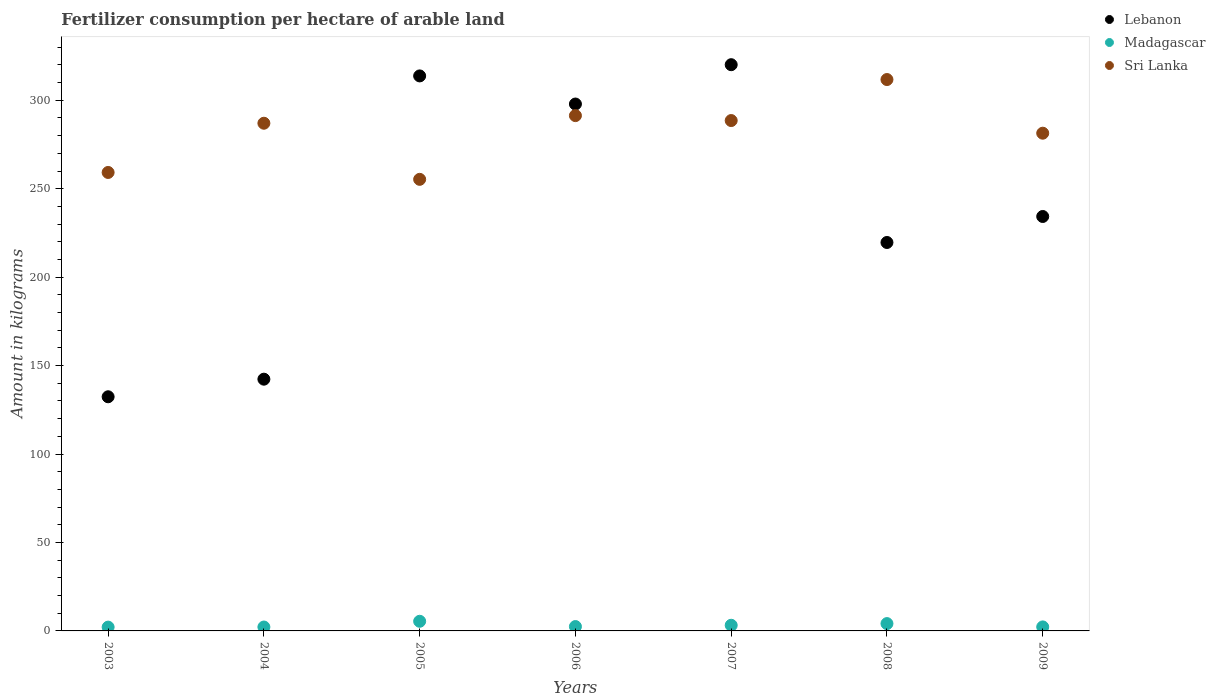Is the number of dotlines equal to the number of legend labels?
Your response must be concise. Yes. What is the amount of fertilizer consumption in Lebanon in 2007?
Make the answer very short. 320.1. Across all years, what is the maximum amount of fertilizer consumption in Lebanon?
Keep it short and to the point. 320.1. Across all years, what is the minimum amount of fertilizer consumption in Sri Lanka?
Ensure brevity in your answer.  255.29. In which year was the amount of fertilizer consumption in Madagascar maximum?
Your answer should be very brief. 2005. In which year was the amount of fertilizer consumption in Lebanon minimum?
Provide a succinct answer. 2003. What is the total amount of fertilizer consumption in Madagascar in the graph?
Provide a succinct answer. 21.87. What is the difference between the amount of fertilizer consumption in Sri Lanka in 2005 and that in 2006?
Provide a succinct answer. -36.02. What is the difference between the amount of fertilizer consumption in Lebanon in 2006 and the amount of fertilizer consumption in Madagascar in 2004?
Your response must be concise. 295.66. What is the average amount of fertilizer consumption in Madagascar per year?
Provide a succinct answer. 3.12. In the year 2008, what is the difference between the amount of fertilizer consumption in Sri Lanka and amount of fertilizer consumption in Madagascar?
Offer a very short reply. 307.57. What is the ratio of the amount of fertilizer consumption in Madagascar in 2006 to that in 2007?
Keep it short and to the point. 0.77. Is the difference between the amount of fertilizer consumption in Sri Lanka in 2004 and 2005 greater than the difference between the amount of fertilizer consumption in Madagascar in 2004 and 2005?
Provide a succinct answer. Yes. What is the difference between the highest and the second highest amount of fertilizer consumption in Sri Lanka?
Offer a terse response. 20.4. What is the difference between the highest and the lowest amount of fertilizer consumption in Madagascar?
Make the answer very short. 3.3. Is the sum of the amount of fertilizer consumption in Madagascar in 2003 and 2005 greater than the maximum amount of fertilizer consumption in Sri Lanka across all years?
Keep it short and to the point. No. Is it the case that in every year, the sum of the amount of fertilizer consumption in Sri Lanka and amount of fertilizer consumption in Madagascar  is greater than the amount of fertilizer consumption in Lebanon?
Offer a very short reply. No. Is the amount of fertilizer consumption in Madagascar strictly greater than the amount of fertilizer consumption in Lebanon over the years?
Give a very brief answer. No. Are the values on the major ticks of Y-axis written in scientific E-notation?
Provide a succinct answer. No. Does the graph contain any zero values?
Offer a terse response. No. Does the graph contain grids?
Your answer should be compact. No. How many legend labels are there?
Ensure brevity in your answer.  3. How are the legend labels stacked?
Your response must be concise. Vertical. What is the title of the graph?
Your answer should be compact. Fertilizer consumption per hectare of arable land. What is the label or title of the X-axis?
Give a very brief answer. Years. What is the label or title of the Y-axis?
Keep it short and to the point. Amount in kilograms. What is the Amount in kilograms of Lebanon in 2003?
Offer a terse response. 132.38. What is the Amount in kilograms in Madagascar in 2003?
Offer a terse response. 2.15. What is the Amount in kilograms in Sri Lanka in 2003?
Your answer should be very brief. 259.18. What is the Amount in kilograms of Lebanon in 2004?
Your answer should be very brief. 142.32. What is the Amount in kilograms in Madagascar in 2004?
Provide a short and direct response. 2.2. What is the Amount in kilograms in Sri Lanka in 2004?
Offer a very short reply. 287.01. What is the Amount in kilograms in Lebanon in 2005?
Provide a succinct answer. 313.76. What is the Amount in kilograms in Madagascar in 2005?
Offer a very short reply. 5.45. What is the Amount in kilograms in Sri Lanka in 2005?
Give a very brief answer. 255.29. What is the Amount in kilograms in Lebanon in 2006?
Ensure brevity in your answer.  297.87. What is the Amount in kilograms in Madagascar in 2006?
Your answer should be very brief. 2.47. What is the Amount in kilograms in Sri Lanka in 2006?
Provide a succinct answer. 291.32. What is the Amount in kilograms in Lebanon in 2007?
Your response must be concise. 320.1. What is the Amount in kilograms of Madagascar in 2007?
Ensure brevity in your answer.  3.19. What is the Amount in kilograms in Sri Lanka in 2007?
Give a very brief answer. 288.52. What is the Amount in kilograms of Lebanon in 2008?
Make the answer very short. 219.59. What is the Amount in kilograms in Madagascar in 2008?
Give a very brief answer. 4.14. What is the Amount in kilograms in Sri Lanka in 2008?
Your answer should be compact. 311.71. What is the Amount in kilograms in Lebanon in 2009?
Offer a very short reply. 234.29. What is the Amount in kilograms in Madagascar in 2009?
Your response must be concise. 2.27. What is the Amount in kilograms in Sri Lanka in 2009?
Ensure brevity in your answer.  281.38. Across all years, what is the maximum Amount in kilograms of Lebanon?
Your response must be concise. 320.1. Across all years, what is the maximum Amount in kilograms of Madagascar?
Ensure brevity in your answer.  5.45. Across all years, what is the maximum Amount in kilograms of Sri Lanka?
Give a very brief answer. 311.71. Across all years, what is the minimum Amount in kilograms of Lebanon?
Offer a terse response. 132.38. Across all years, what is the minimum Amount in kilograms of Madagascar?
Your answer should be very brief. 2.15. Across all years, what is the minimum Amount in kilograms of Sri Lanka?
Ensure brevity in your answer.  255.29. What is the total Amount in kilograms of Lebanon in the graph?
Keep it short and to the point. 1660.31. What is the total Amount in kilograms of Madagascar in the graph?
Offer a terse response. 21.87. What is the total Amount in kilograms of Sri Lanka in the graph?
Provide a succinct answer. 1974.41. What is the difference between the Amount in kilograms of Lebanon in 2003 and that in 2004?
Keep it short and to the point. -9.94. What is the difference between the Amount in kilograms in Madagascar in 2003 and that in 2004?
Your answer should be very brief. -0.05. What is the difference between the Amount in kilograms in Sri Lanka in 2003 and that in 2004?
Make the answer very short. -27.83. What is the difference between the Amount in kilograms in Lebanon in 2003 and that in 2005?
Your response must be concise. -181.39. What is the difference between the Amount in kilograms in Madagascar in 2003 and that in 2005?
Your answer should be very brief. -3.3. What is the difference between the Amount in kilograms of Sri Lanka in 2003 and that in 2005?
Your answer should be very brief. 3.89. What is the difference between the Amount in kilograms in Lebanon in 2003 and that in 2006?
Make the answer very short. -165.49. What is the difference between the Amount in kilograms of Madagascar in 2003 and that in 2006?
Make the answer very short. -0.32. What is the difference between the Amount in kilograms in Sri Lanka in 2003 and that in 2006?
Ensure brevity in your answer.  -32.13. What is the difference between the Amount in kilograms of Lebanon in 2003 and that in 2007?
Keep it short and to the point. -187.73. What is the difference between the Amount in kilograms of Madagascar in 2003 and that in 2007?
Provide a succinct answer. -1.04. What is the difference between the Amount in kilograms of Sri Lanka in 2003 and that in 2007?
Offer a very short reply. -29.34. What is the difference between the Amount in kilograms of Lebanon in 2003 and that in 2008?
Your answer should be compact. -87.22. What is the difference between the Amount in kilograms of Madagascar in 2003 and that in 2008?
Give a very brief answer. -1.99. What is the difference between the Amount in kilograms of Sri Lanka in 2003 and that in 2008?
Keep it short and to the point. -52.53. What is the difference between the Amount in kilograms in Lebanon in 2003 and that in 2009?
Offer a very short reply. -101.92. What is the difference between the Amount in kilograms in Madagascar in 2003 and that in 2009?
Offer a very short reply. -0.12. What is the difference between the Amount in kilograms of Sri Lanka in 2003 and that in 2009?
Provide a short and direct response. -22.19. What is the difference between the Amount in kilograms of Lebanon in 2004 and that in 2005?
Your answer should be compact. -171.44. What is the difference between the Amount in kilograms in Madagascar in 2004 and that in 2005?
Ensure brevity in your answer.  -3.25. What is the difference between the Amount in kilograms in Sri Lanka in 2004 and that in 2005?
Your answer should be compact. 31.72. What is the difference between the Amount in kilograms in Lebanon in 2004 and that in 2006?
Your answer should be compact. -155.55. What is the difference between the Amount in kilograms of Madagascar in 2004 and that in 2006?
Provide a short and direct response. -0.26. What is the difference between the Amount in kilograms in Sri Lanka in 2004 and that in 2006?
Provide a short and direct response. -4.31. What is the difference between the Amount in kilograms in Lebanon in 2004 and that in 2007?
Keep it short and to the point. -177.79. What is the difference between the Amount in kilograms in Madagascar in 2004 and that in 2007?
Offer a terse response. -0.99. What is the difference between the Amount in kilograms of Sri Lanka in 2004 and that in 2007?
Your response must be concise. -1.51. What is the difference between the Amount in kilograms of Lebanon in 2004 and that in 2008?
Provide a short and direct response. -77.28. What is the difference between the Amount in kilograms of Madagascar in 2004 and that in 2008?
Your response must be concise. -1.94. What is the difference between the Amount in kilograms of Sri Lanka in 2004 and that in 2008?
Make the answer very short. -24.7. What is the difference between the Amount in kilograms in Lebanon in 2004 and that in 2009?
Provide a short and direct response. -91.97. What is the difference between the Amount in kilograms of Madagascar in 2004 and that in 2009?
Your response must be concise. -0.06. What is the difference between the Amount in kilograms in Sri Lanka in 2004 and that in 2009?
Give a very brief answer. 5.63. What is the difference between the Amount in kilograms in Lebanon in 2005 and that in 2006?
Your response must be concise. 15.89. What is the difference between the Amount in kilograms in Madagascar in 2005 and that in 2006?
Your answer should be very brief. 2.98. What is the difference between the Amount in kilograms in Sri Lanka in 2005 and that in 2006?
Ensure brevity in your answer.  -36.02. What is the difference between the Amount in kilograms in Lebanon in 2005 and that in 2007?
Provide a succinct answer. -6.34. What is the difference between the Amount in kilograms in Madagascar in 2005 and that in 2007?
Keep it short and to the point. 2.26. What is the difference between the Amount in kilograms in Sri Lanka in 2005 and that in 2007?
Offer a very short reply. -33.23. What is the difference between the Amount in kilograms of Lebanon in 2005 and that in 2008?
Provide a succinct answer. 94.17. What is the difference between the Amount in kilograms in Madagascar in 2005 and that in 2008?
Make the answer very short. 1.31. What is the difference between the Amount in kilograms in Sri Lanka in 2005 and that in 2008?
Your answer should be compact. -56.42. What is the difference between the Amount in kilograms of Lebanon in 2005 and that in 2009?
Offer a terse response. 79.47. What is the difference between the Amount in kilograms of Madagascar in 2005 and that in 2009?
Give a very brief answer. 3.18. What is the difference between the Amount in kilograms of Sri Lanka in 2005 and that in 2009?
Your answer should be very brief. -26.08. What is the difference between the Amount in kilograms in Lebanon in 2006 and that in 2007?
Your response must be concise. -22.24. What is the difference between the Amount in kilograms in Madagascar in 2006 and that in 2007?
Give a very brief answer. -0.73. What is the difference between the Amount in kilograms in Sri Lanka in 2006 and that in 2007?
Offer a very short reply. 2.79. What is the difference between the Amount in kilograms of Lebanon in 2006 and that in 2008?
Your answer should be compact. 78.27. What is the difference between the Amount in kilograms in Madagascar in 2006 and that in 2008?
Your response must be concise. -1.68. What is the difference between the Amount in kilograms in Sri Lanka in 2006 and that in 2008?
Ensure brevity in your answer.  -20.4. What is the difference between the Amount in kilograms of Lebanon in 2006 and that in 2009?
Ensure brevity in your answer.  63.58. What is the difference between the Amount in kilograms of Madagascar in 2006 and that in 2009?
Your answer should be very brief. 0.2. What is the difference between the Amount in kilograms of Sri Lanka in 2006 and that in 2009?
Keep it short and to the point. 9.94. What is the difference between the Amount in kilograms in Lebanon in 2007 and that in 2008?
Keep it short and to the point. 100.51. What is the difference between the Amount in kilograms in Madagascar in 2007 and that in 2008?
Give a very brief answer. -0.95. What is the difference between the Amount in kilograms in Sri Lanka in 2007 and that in 2008?
Offer a very short reply. -23.19. What is the difference between the Amount in kilograms of Lebanon in 2007 and that in 2009?
Provide a succinct answer. 85.81. What is the difference between the Amount in kilograms in Madagascar in 2007 and that in 2009?
Ensure brevity in your answer.  0.93. What is the difference between the Amount in kilograms of Sri Lanka in 2007 and that in 2009?
Make the answer very short. 7.15. What is the difference between the Amount in kilograms in Lebanon in 2008 and that in 2009?
Your answer should be compact. -14.7. What is the difference between the Amount in kilograms in Madagascar in 2008 and that in 2009?
Your response must be concise. 1.88. What is the difference between the Amount in kilograms in Sri Lanka in 2008 and that in 2009?
Your response must be concise. 30.34. What is the difference between the Amount in kilograms in Lebanon in 2003 and the Amount in kilograms in Madagascar in 2004?
Make the answer very short. 130.17. What is the difference between the Amount in kilograms in Lebanon in 2003 and the Amount in kilograms in Sri Lanka in 2004?
Give a very brief answer. -154.63. What is the difference between the Amount in kilograms in Madagascar in 2003 and the Amount in kilograms in Sri Lanka in 2004?
Your answer should be very brief. -284.86. What is the difference between the Amount in kilograms in Lebanon in 2003 and the Amount in kilograms in Madagascar in 2005?
Make the answer very short. 126.92. What is the difference between the Amount in kilograms in Lebanon in 2003 and the Amount in kilograms in Sri Lanka in 2005?
Your answer should be compact. -122.92. What is the difference between the Amount in kilograms in Madagascar in 2003 and the Amount in kilograms in Sri Lanka in 2005?
Your answer should be very brief. -253.14. What is the difference between the Amount in kilograms in Lebanon in 2003 and the Amount in kilograms in Madagascar in 2006?
Provide a short and direct response. 129.91. What is the difference between the Amount in kilograms in Lebanon in 2003 and the Amount in kilograms in Sri Lanka in 2006?
Ensure brevity in your answer.  -158.94. What is the difference between the Amount in kilograms of Madagascar in 2003 and the Amount in kilograms of Sri Lanka in 2006?
Offer a terse response. -289.17. What is the difference between the Amount in kilograms of Lebanon in 2003 and the Amount in kilograms of Madagascar in 2007?
Your response must be concise. 129.18. What is the difference between the Amount in kilograms of Lebanon in 2003 and the Amount in kilograms of Sri Lanka in 2007?
Make the answer very short. -156.15. What is the difference between the Amount in kilograms in Madagascar in 2003 and the Amount in kilograms in Sri Lanka in 2007?
Offer a very short reply. -286.38. What is the difference between the Amount in kilograms of Lebanon in 2003 and the Amount in kilograms of Madagascar in 2008?
Ensure brevity in your answer.  128.23. What is the difference between the Amount in kilograms in Lebanon in 2003 and the Amount in kilograms in Sri Lanka in 2008?
Keep it short and to the point. -179.34. What is the difference between the Amount in kilograms of Madagascar in 2003 and the Amount in kilograms of Sri Lanka in 2008?
Provide a succinct answer. -309.56. What is the difference between the Amount in kilograms of Lebanon in 2003 and the Amount in kilograms of Madagascar in 2009?
Your answer should be compact. 130.11. What is the difference between the Amount in kilograms of Lebanon in 2003 and the Amount in kilograms of Sri Lanka in 2009?
Keep it short and to the point. -149. What is the difference between the Amount in kilograms of Madagascar in 2003 and the Amount in kilograms of Sri Lanka in 2009?
Provide a succinct answer. -279.23. What is the difference between the Amount in kilograms in Lebanon in 2004 and the Amount in kilograms in Madagascar in 2005?
Keep it short and to the point. 136.87. What is the difference between the Amount in kilograms in Lebanon in 2004 and the Amount in kilograms in Sri Lanka in 2005?
Make the answer very short. -112.97. What is the difference between the Amount in kilograms of Madagascar in 2004 and the Amount in kilograms of Sri Lanka in 2005?
Your response must be concise. -253.09. What is the difference between the Amount in kilograms of Lebanon in 2004 and the Amount in kilograms of Madagascar in 2006?
Your response must be concise. 139.85. What is the difference between the Amount in kilograms of Lebanon in 2004 and the Amount in kilograms of Sri Lanka in 2006?
Make the answer very short. -149. What is the difference between the Amount in kilograms in Madagascar in 2004 and the Amount in kilograms in Sri Lanka in 2006?
Provide a succinct answer. -289.11. What is the difference between the Amount in kilograms in Lebanon in 2004 and the Amount in kilograms in Madagascar in 2007?
Provide a succinct answer. 139.13. What is the difference between the Amount in kilograms in Lebanon in 2004 and the Amount in kilograms in Sri Lanka in 2007?
Provide a short and direct response. -146.21. What is the difference between the Amount in kilograms in Madagascar in 2004 and the Amount in kilograms in Sri Lanka in 2007?
Give a very brief answer. -286.32. What is the difference between the Amount in kilograms of Lebanon in 2004 and the Amount in kilograms of Madagascar in 2008?
Your answer should be compact. 138.18. What is the difference between the Amount in kilograms in Lebanon in 2004 and the Amount in kilograms in Sri Lanka in 2008?
Keep it short and to the point. -169.39. What is the difference between the Amount in kilograms in Madagascar in 2004 and the Amount in kilograms in Sri Lanka in 2008?
Keep it short and to the point. -309.51. What is the difference between the Amount in kilograms in Lebanon in 2004 and the Amount in kilograms in Madagascar in 2009?
Offer a very short reply. 140.05. What is the difference between the Amount in kilograms in Lebanon in 2004 and the Amount in kilograms in Sri Lanka in 2009?
Keep it short and to the point. -139.06. What is the difference between the Amount in kilograms of Madagascar in 2004 and the Amount in kilograms of Sri Lanka in 2009?
Offer a terse response. -279.17. What is the difference between the Amount in kilograms in Lebanon in 2005 and the Amount in kilograms in Madagascar in 2006?
Offer a very short reply. 311.3. What is the difference between the Amount in kilograms in Lebanon in 2005 and the Amount in kilograms in Sri Lanka in 2006?
Keep it short and to the point. 22.45. What is the difference between the Amount in kilograms in Madagascar in 2005 and the Amount in kilograms in Sri Lanka in 2006?
Your response must be concise. -285.86. What is the difference between the Amount in kilograms of Lebanon in 2005 and the Amount in kilograms of Madagascar in 2007?
Your answer should be very brief. 310.57. What is the difference between the Amount in kilograms of Lebanon in 2005 and the Amount in kilograms of Sri Lanka in 2007?
Offer a terse response. 25.24. What is the difference between the Amount in kilograms of Madagascar in 2005 and the Amount in kilograms of Sri Lanka in 2007?
Offer a terse response. -283.07. What is the difference between the Amount in kilograms in Lebanon in 2005 and the Amount in kilograms in Madagascar in 2008?
Provide a succinct answer. 309.62. What is the difference between the Amount in kilograms in Lebanon in 2005 and the Amount in kilograms in Sri Lanka in 2008?
Your answer should be very brief. 2.05. What is the difference between the Amount in kilograms of Madagascar in 2005 and the Amount in kilograms of Sri Lanka in 2008?
Provide a short and direct response. -306.26. What is the difference between the Amount in kilograms of Lebanon in 2005 and the Amount in kilograms of Madagascar in 2009?
Offer a terse response. 311.49. What is the difference between the Amount in kilograms of Lebanon in 2005 and the Amount in kilograms of Sri Lanka in 2009?
Your response must be concise. 32.39. What is the difference between the Amount in kilograms in Madagascar in 2005 and the Amount in kilograms in Sri Lanka in 2009?
Make the answer very short. -275.93. What is the difference between the Amount in kilograms in Lebanon in 2006 and the Amount in kilograms in Madagascar in 2007?
Offer a very short reply. 294.68. What is the difference between the Amount in kilograms of Lebanon in 2006 and the Amount in kilograms of Sri Lanka in 2007?
Provide a succinct answer. 9.34. What is the difference between the Amount in kilograms of Madagascar in 2006 and the Amount in kilograms of Sri Lanka in 2007?
Your answer should be compact. -286.06. What is the difference between the Amount in kilograms in Lebanon in 2006 and the Amount in kilograms in Madagascar in 2008?
Your answer should be very brief. 293.72. What is the difference between the Amount in kilograms in Lebanon in 2006 and the Amount in kilograms in Sri Lanka in 2008?
Give a very brief answer. -13.84. What is the difference between the Amount in kilograms of Madagascar in 2006 and the Amount in kilograms of Sri Lanka in 2008?
Provide a short and direct response. -309.25. What is the difference between the Amount in kilograms in Lebanon in 2006 and the Amount in kilograms in Madagascar in 2009?
Provide a succinct answer. 295.6. What is the difference between the Amount in kilograms in Lebanon in 2006 and the Amount in kilograms in Sri Lanka in 2009?
Keep it short and to the point. 16.49. What is the difference between the Amount in kilograms of Madagascar in 2006 and the Amount in kilograms of Sri Lanka in 2009?
Your response must be concise. -278.91. What is the difference between the Amount in kilograms in Lebanon in 2007 and the Amount in kilograms in Madagascar in 2008?
Provide a short and direct response. 315.96. What is the difference between the Amount in kilograms in Lebanon in 2007 and the Amount in kilograms in Sri Lanka in 2008?
Your answer should be very brief. 8.39. What is the difference between the Amount in kilograms of Madagascar in 2007 and the Amount in kilograms of Sri Lanka in 2008?
Make the answer very short. -308.52. What is the difference between the Amount in kilograms in Lebanon in 2007 and the Amount in kilograms in Madagascar in 2009?
Offer a terse response. 317.84. What is the difference between the Amount in kilograms of Lebanon in 2007 and the Amount in kilograms of Sri Lanka in 2009?
Make the answer very short. 38.73. What is the difference between the Amount in kilograms of Madagascar in 2007 and the Amount in kilograms of Sri Lanka in 2009?
Offer a terse response. -278.18. What is the difference between the Amount in kilograms in Lebanon in 2008 and the Amount in kilograms in Madagascar in 2009?
Make the answer very short. 217.33. What is the difference between the Amount in kilograms in Lebanon in 2008 and the Amount in kilograms in Sri Lanka in 2009?
Keep it short and to the point. -61.78. What is the difference between the Amount in kilograms in Madagascar in 2008 and the Amount in kilograms in Sri Lanka in 2009?
Your response must be concise. -277.23. What is the average Amount in kilograms in Lebanon per year?
Ensure brevity in your answer.  237.19. What is the average Amount in kilograms in Madagascar per year?
Offer a terse response. 3.12. What is the average Amount in kilograms of Sri Lanka per year?
Ensure brevity in your answer.  282.06. In the year 2003, what is the difference between the Amount in kilograms in Lebanon and Amount in kilograms in Madagascar?
Give a very brief answer. 130.23. In the year 2003, what is the difference between the Amount in kilograms of Lebanon and Amount in kilograms of Sri Lanka?
Offer a terse response. -126.81. In the year 2003, what is the difference between the Amount in kilograms in Madagascar and Amount in kilograms in Sri Lanka?
Your response must be concise. -257.04. In the year 2004, what is the difference between the Amount in kilograms in Lebanon and Amount in kilograms in Madagascar?
Keep it short and to the point. 140.12. In the year 2004, what is the difference between the Amount in kilograms of Lebanon and Amount in kilograms of Sri Lanka?
Provide a succinct answer. -144.69. In the year 2004, what is the difference between the Amount in kilograms in Madagascar and Amount in kilograms in Sri Lanka?
Provide a short and direct response. -284.81. In the year 2005, what is the difference between the Amount in kilograms in Lebanon and Amount in kilograms in Madagascar?
Provide a succinct answer. 308.31. In the year 2005, what is the difference between the Amount in kilograms of Lebanon and Amount in kilograms of Sri Lanka?
Your answer should be very brief. 58.47. In the year 2005, what is the difference between the Amount in kilograms of Madagascar and Amount in kilograms of Sri Lanka?
Offer a terse response. -249.84. In the year 2006, what is the difference between the Amount in kilograms of Lebanon and Amount in kilograms of Madagascar?
Provide a succinct answer. 295.4. In the year 2006, what is the difference between the Amount in kilograms of Lebanon and Amount in kilograms of Sri Lanka?
Offer a very short reply. 6.55. In the year 2006, what is the difference between the Amount in kilograms of Madagascar and Amount in kilograms of Sri Lanka?
Give a very brief answer. -288.85. In the year 2007, what is the difference between the Amount in kilograms in Lebanon and Amount in kilograms in Madagascar?
Keep it short and to the point. 316.91. In the year 2007, what is the difference between the Amount in kilograms in Lebanon and Amount in kilograms in Sri Lanka?
Your answer should be compact. 31.58. In the year 2007, what is the difference between the Amount in kilograms in Madagascar and Amount in kilograms in Sri Lanka?
Provide a succinct answer. -285.33. In the year 2008, what is the difference between the Amount in kilograms of Lebanon and Amount in kilograms of Madagascar?
Provide a short and direct response. 215.45. In the year 2008, what is the difference between the Amount in kilograms of Lebanon and Amount in kilograms of Sri Lanka?
Offer a very short reply. -92.12. In the year 2008, what is the difference between the Amount in kilograms of Madagascar and Amount in kilograms of Sri Lanka?
Give a very brief answer. -307.57. In the year 2009, what is the difference between the Amount in kilograms in Lebanon and Amount in kilograms in Madagascar?
Offer a very short reply. 232.03. In the year 2009, what is the difference between the Amount in kilograms in Lebanon and Amount in kilograms in Sri Lanka?
Give a very brief answer. -47.08. In the year 2009, what is the difference between the Amount in kilograms of Madagascar and Amount in kilograms of Sri Lanka?
Make the answer very short. -279.11. What is the ratio of the Amount in kilograms in Lebanon in 2003 to that in 2004?
Offer a very short reply. 0.93. What is the ratio of the Amount in kilograms in Madagascar in 2003 to that in 2004?
Ensure brevity in your answer.  0.98. What is the ratio of the Amount in kilograms in Sri Lanka in 2003 to that in 2004?
Your answer should be very brief. 0.9. What is the ratio of the Amount in kilograms in Lebanon in 2003 to that in 2005?
Ensure brevity in your answer.  0.42. What is the ratio of the Amount in kilograms of Madagascar in 2003 to that in 2005?
Offer a very short reply. 0.39. What is the ratio of the Amount in kilograms of Sri Lanka in 2003 to that in 2005?
Offer a terse response. 1.02. What is the ratio of the Amount in kilograms of Lebanon in 2003 to that in 2006?
Your response must be concise. 0.44. What is the ratio of the Amount in kilograms in Madagascar in 2003 to that in 2006?
Give a very brief answer. 0.87. What is the ratio of the Amount in kilograms of Sri Lanka in 2003 to that in 2006?
Provide a succinct answer. 0.89. What is the ratio of the Amount in kilograms in Lebanon in 2003 to that in 2007?
Your answer should be compact. 0.41. What is the ratio of the Amount in kilograms of Madagascar in 2003 to that in 2007?
Ensure brevity in your answer.  0.67. What is the ratio of the Amount in kilograms in Sri Lanka in 2003 to that in 2007?
Keep it short and to the point. 0.9. What is the ratio of the Amount in kilograms of Lebanon in 2003 to that in 2008?
Provide a short and direct response. 0.6. What is the ratio of the Amount in kilograms of Madagascar in 2003 to that in 2008?
Ensure brevity in your answer.  0.52. What is the ratio of the Amount in kilograms of Sri Lanka in 2003 to that in 2008?
Provide a short and direct response. 0.83. What is the ratio of the Amount in kilograms of Lebanon in 2003 to that in 2009?
Keep it short and to the point. 0.56. What is the ratio of the Amount in kilograms in Madagascar in 2003 to that in 2009?
Keep it short and to the point. 0.95. What is the ratio of the Amount in kilograms in Sri Lanka in 2003 to that in 2009?
Your response must be concise. 0.92. What is the ratio of the Amount in kilograms in Lebanon in 2004 to that in 2005?
Provide a short and direct response. 0.45. What is the ratio of the Amount in kilograms of Madagascar in 2004 to that in 2005?
Your answer should be compact. 0.4. What is the ratio of the Amount in kilograms of Sri Lanka in 2004 to that in 2005?
Your response must be concise. 1.12. What is the ratio of the Amount in kilograms of Lebanon in 2004 to that in 2006?
Give a very brief answer. 0.48. What is the ratio of the Amount in kilograms in Madagascar in 2004 to that in 2006?
Provide a short and direct response. 0.89. What is the ratio of the Amount in kilograms in Sri Lanka in 2004 to that in 2006?
Keep it short and to the point. 0.99. What is the ratio of the Amount in kilograms in Lebanon in 2004 to that in 2007?
Provide a succinct answer. 0.44. What is the ratio of the Amount in kilograms in Madagascar in 2004 to that in 2007?
Ensure brevity in your answer.  0.69. What is the ratio of the Amount in kilograms in Lebanon in 2004 to that in 2008?
Your answer should be very brief. 0.65. What is the ratio of the Amount in kilograms of Madagascar in 2004 to that in 2008?
Offer a terse response. 0.53. What is the ratio of the Amount in kilograms of Sri Lanka in 2004 to that in 2008?
Provide a succinct answer. 0.92. What is the ratio of the Amount in kilograms in Lebanon in 2004 to that in 2009?
Offer a terse response. 0.61. What is the ratio of the Amount in kilograms in Madagascar in 2004 to that in 2009?
Offer a very short reply. 0.97. What is the ratio of the Amount in kilograms in Sri Lanka in 2004 to that in 2009?
Your answer should be very brief. 1.02. What is the ratio of the Amount in kilograms of Lebanon in 2005 to that in 2006?
Your answer should be compact. 1.05. What is the ratio of the Amount in kilograms in Madagascar in 2005 to that in 2006?
Your response must be concise. 2.21. What is the ratio of the Amount in kilograms of Sri Lanka in 2005 to that in 2006?
Offer a very short reply. 0.88. What is the ratio of the Amount in kilograms of Lebanon in 2005 to that in 2007?
Ensure brevity in your answer.  0.98. What is the ratio of the Amount in kilograms in Madagascar in 2005 to that in 2007?
Your response must be concise. 1.71. What is the ratio of the Amount in kilograms in Sri Lanka in 2005 to that in 2007?
Your answer should be compact. 0.88. What is the ratio of the Amount in kilograms in Lebanon in 2005 to that in 2008?
Offer a terse response. 1.43. What is the ratio of the Amount in kilograms of Madagascar in 2005 to that in 2008?
Your answer should be compact. 1.32. What is the ratio of the Amount in kilograms of Sri Lanka in 2005 to that in 2008?
Keep it short and to the point. 0.82. What is the ratio of the Amount in kilograms of Lebanon in 2005 to that in 2009?
Provide a succinct answer. 1.34. What is the ratio of the Amount in kilograms in Madagascar in 2005 to that in 2009?
Ensure brevity in your answer.  2.4. What is the ratio of the Amount in kilograms in Sri Lanka in 2005 to that in 2009?
Make the answer very short. 0.91. What is the ratio of the Amount in kilograms of Lebanon in 2006 to that in 2007?
Your answer should be compact. 0.93. What is the ratio of the Amount in kilograms in Madagascar in 2006 to that in 2007?
Offer a terse response. 0.77. What is the ratio of the Amount in kilograms in Sri Lanka in 2006 to that in 2007?
Your response must be concise. 1.01. What is the ratio of the Amount in kilograms in Lebanon in 2006 to that in 2008?
Your answer should be compact. 1.36. What is the ratio of the Amount in kilograms in Madagascar in 2006 to that in 2008?
Offer a terse response. 0.6. What is the ratio of the Amount in kilograms of Sri Lanka in 2006 to that in 2008?
Give a very brief answer. 0.93. What is the ratio of the Amount in kilograms in Lebanon in 2006 to that in 2009?
Ensure brevity in your answer.  1.27. What is the ratio of the Amount in kilograms in Madagascar in 2006 to that in 2009?
Offer a very short reply. 1.09. What is the ratio of the Amount in kilograms of Sri Lanka in 2006 to that in 2009?
Keep it short and to the point. 1.04. What is the ratio of the Amount in kilograms in Lebanon in 2007 to that in 2008?
Your answer should be compact. 1.46. What is the ratio of the Amount in kilograms in Madagascar in 2007 to that in 2008?
Your answer should be compact. 0.77. What is the ratio of the Amount in kilograms of Sri Lanka in 2007 to that in 2008?
Provide a succinct answer. 0.93. What is the ratio of the Amount in kilograms in Lebanon in 2007 to that in 2009?
Ensure brevity in your answer.  1.37. What is the ratio of the Amount in kilograms of Madagascar in 2007 to that in 2009?
Give a very brief answer. 1.41. What is the ratio of the Amount in kilograms in Sri Lanka in 2007 to that in 2009?
Provide a succinct answer. 1.03. What is the ratio of the Amount in kilograms in Lebanon in 2008 to that in 2009?
Make the answer very short. 0.94. What is the ratio of the Amount in kilograms of Madagascar in 2008 to that in 2009?
Your response must be concise. 1.83. What is the ratio of the Amount in kilograms in Sri Lanka in 2008 to that in 2009?
Keep it short and to the point. 1.11. What is the difference between the highest and the second highest Amount in kilograms of Lebanon?
Your response must be concise. 6.34. What is the difference between the highest and the second highest Amount in kilograms in Madagascar?
Make the answer very short. 1.31. What is the difference between the highest and the second highest Amount in kilograms in Sri Lanka?
Offer a very short reply. 20.4. What is the difference between the highest and the lowest Amount in kilograms in Lebanon?
Keep it short and to the point. 187.73. What is the difference between the highest and the lowest Amount in kilograms in Madagascar?
Your answer should be compact. 3.3. What is the difference between the highest and the lowest Amount in kilograms of Sri Lanka?
Provide a succinct answer. 56.42. 